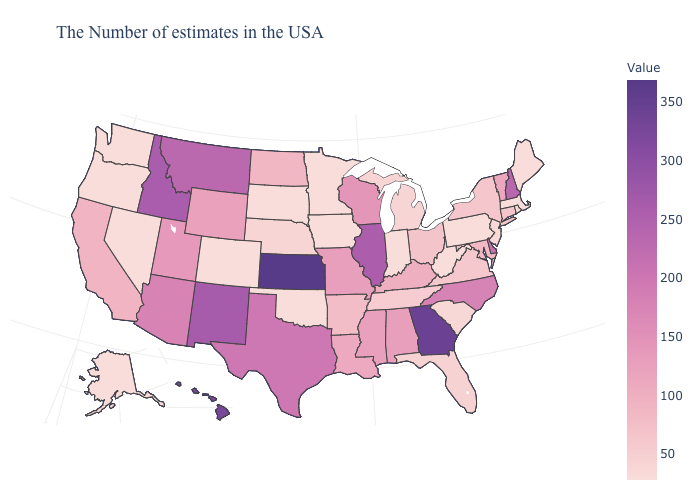Does the map have missing data?
Concise answer only. No. Does Delaware have a lower value than Kansas?
Answer briefly. Yes. Is the legend a continuous bar?
Give a very brief answer. Yes. Is the legend a continuous bar?
Quick response, please. Yes. Which states have the lowest value in the USA?
Short answer required. Maine, Massachusetts, Pennsylvania, West Virginia, Indiana, Minnesota, Iowa, Oklahoma, South Dakota, Colorado, Nevada, Washington, Oregon, Alaska. Among the states that border South Carolina , which have the highest value?
Answer briefly. Georgia. 